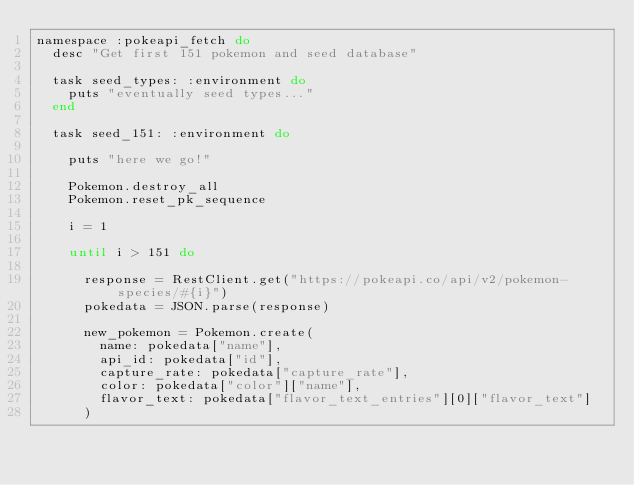<code> <loc_0><loc_0><loc_500><loc_500><_Ruby_>namespace :pokeapi_fetch do
  desc "Get first 151 pokemon and seed database"

  task seed_types: :environment do
    puts "eventually seed types..."
  end

  task seed_151: :environment do

    puts "here we go!"

    Pokemon.destroy_all
    Pokemon.reset_pk_sequence

    i = 1

    until i > 151 do

      response = RestClient.get("https://pokeapi.co/api/v2/pokemon-species/#{i}")
      pokedata = JSON.parse(response)

      new_pokemon = Pokemon.create(
        name: pokedata["name"],
        api_id: pokedata["id"],
        capture_rate: pokedata["capture_rate"],
        color: pokedata["color"]["name"],
        flavor_text: pokedata["flavor_text_entries"][0]["flavor_text"]
      )
      </code> 